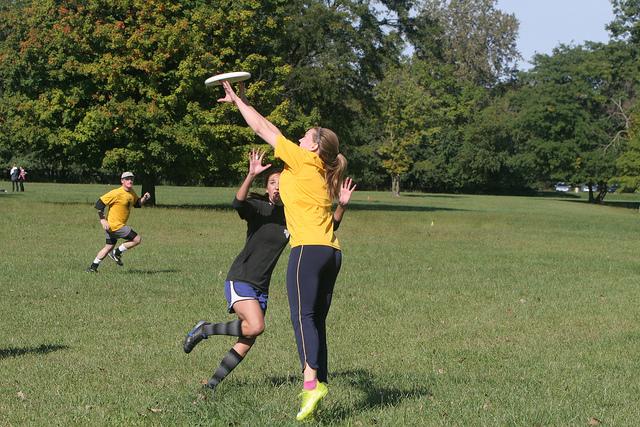How many players are on the field?
Write a very short answer. 3. What game are they playing?
Concise answer only. Frisbee. Is she close to catching the frisbee?
Be succinct. Yes. Do the players cast shadows?
Quick response, please. Yes. 